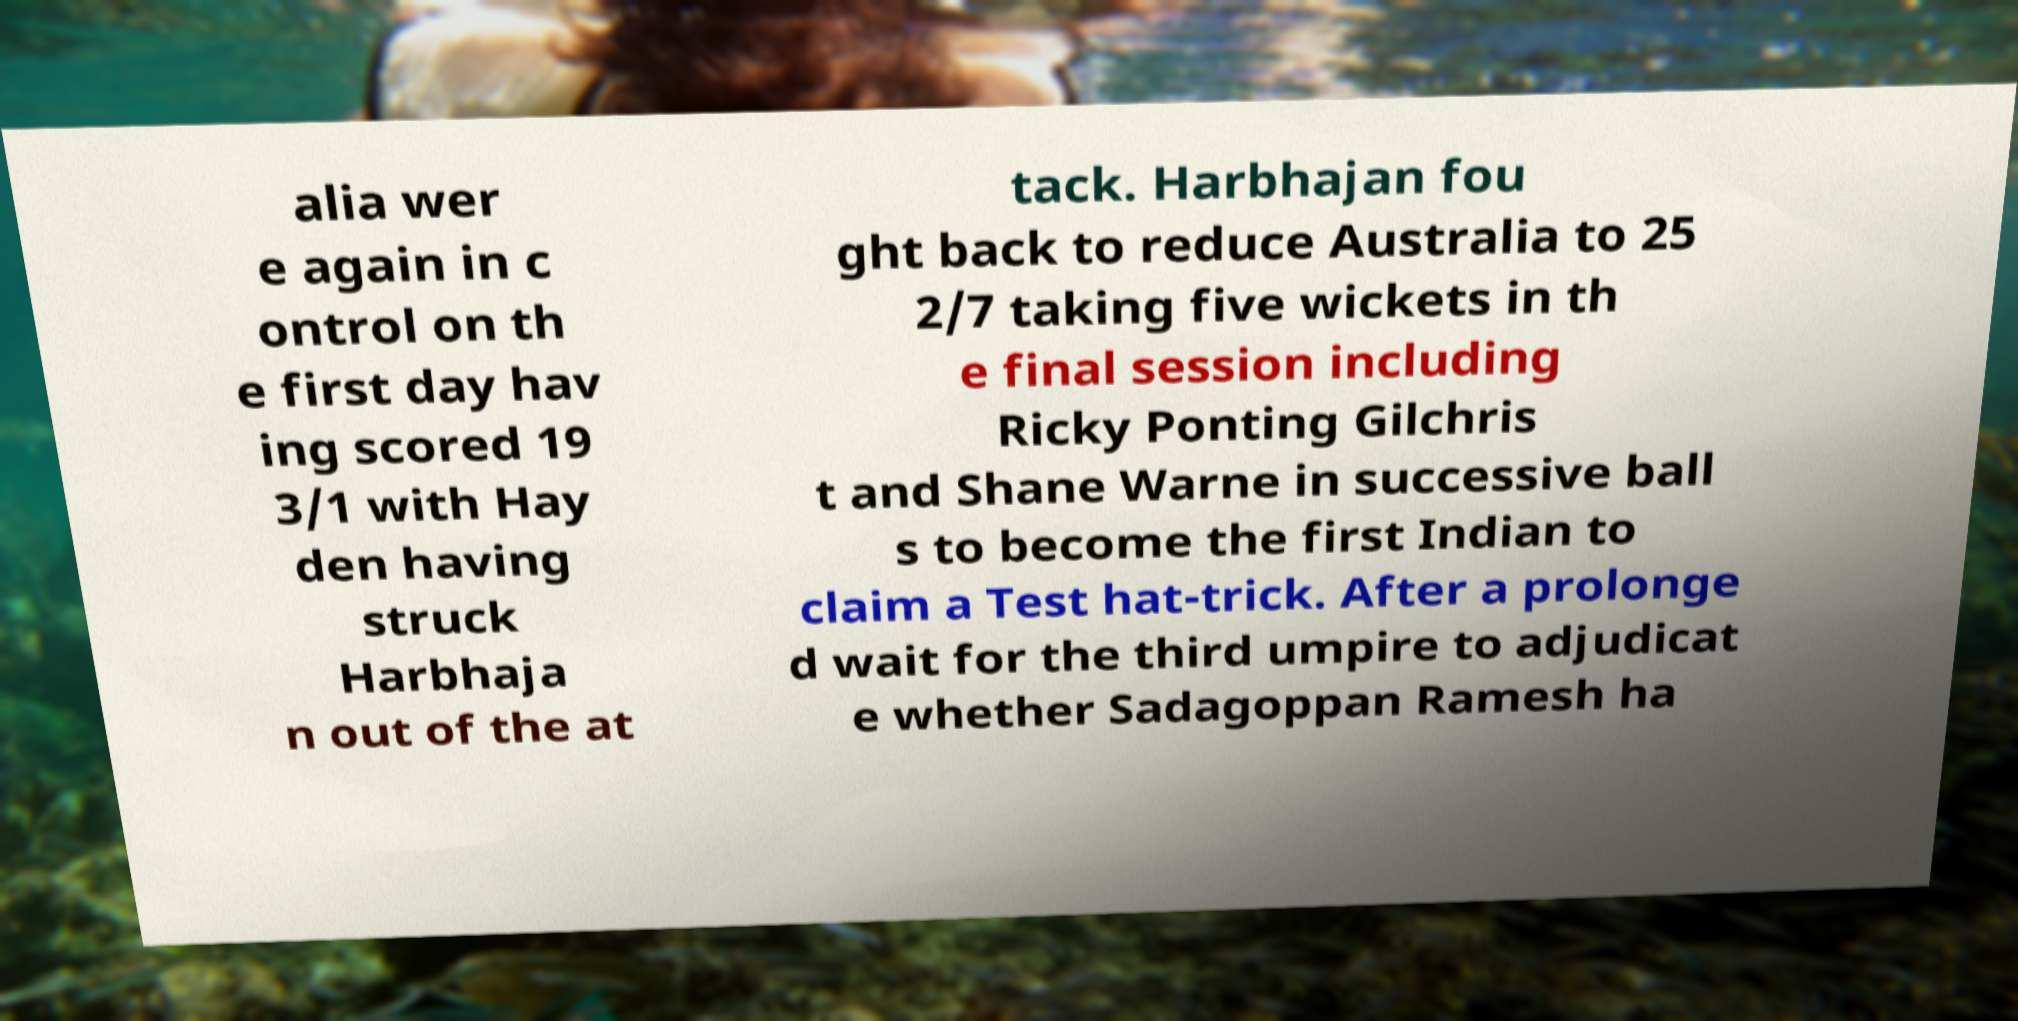What messages or text are displayed in this image? I need them in a readable, typed format. alia wer e again in c ontrol on th e first day hav ing scored 19 3/1 with Hay den having struck Harbhaja n out of the at tack. Harbhajan fou ght back to reduce Australia to 25 2/7 taking five wickets in th e final session including Ricky Ponting Gilchris t and Shane Warne in successive ball s to become the first Indian to claim a Test hat-trick. After a prolonge d wait for the third umpire to adjudicat e whether Sadagoppan Ramesh ha 